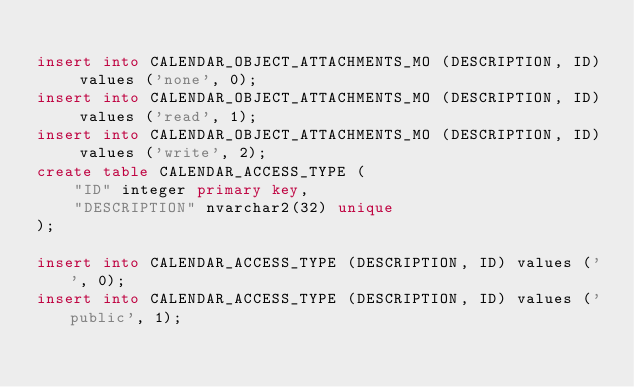<code> <loc_0><loc_0><loc_500><loc_500><_SQL_>
insert into CALENDAR_OBJECT_ATTACHMENTS_MO (DESCRIPTION, ID) values ('none', 0);
insert into CALENDAR_OBJECT_ATTACHMENTS_MO (DESCRIPTION, ID) values ('read', 1);
insert into CALENDAR_OBJECT_ATTACHMENTS_MO (DESCRIPTION, ID) values ('write', 2);
create table CALENDAR_ACCESS_TYPE (
    "ID" integer primary key,
    "DESCRIPTION" nvarchar2(32) unique
);

insert into CALENDAR_ACCESS_TYPE (DESCRIPTION, ID) values ('', 0);
insert into CALENDAR_ACCESS_TYPE (DESCRIPTION, ID) values ('public', 1);</code> 